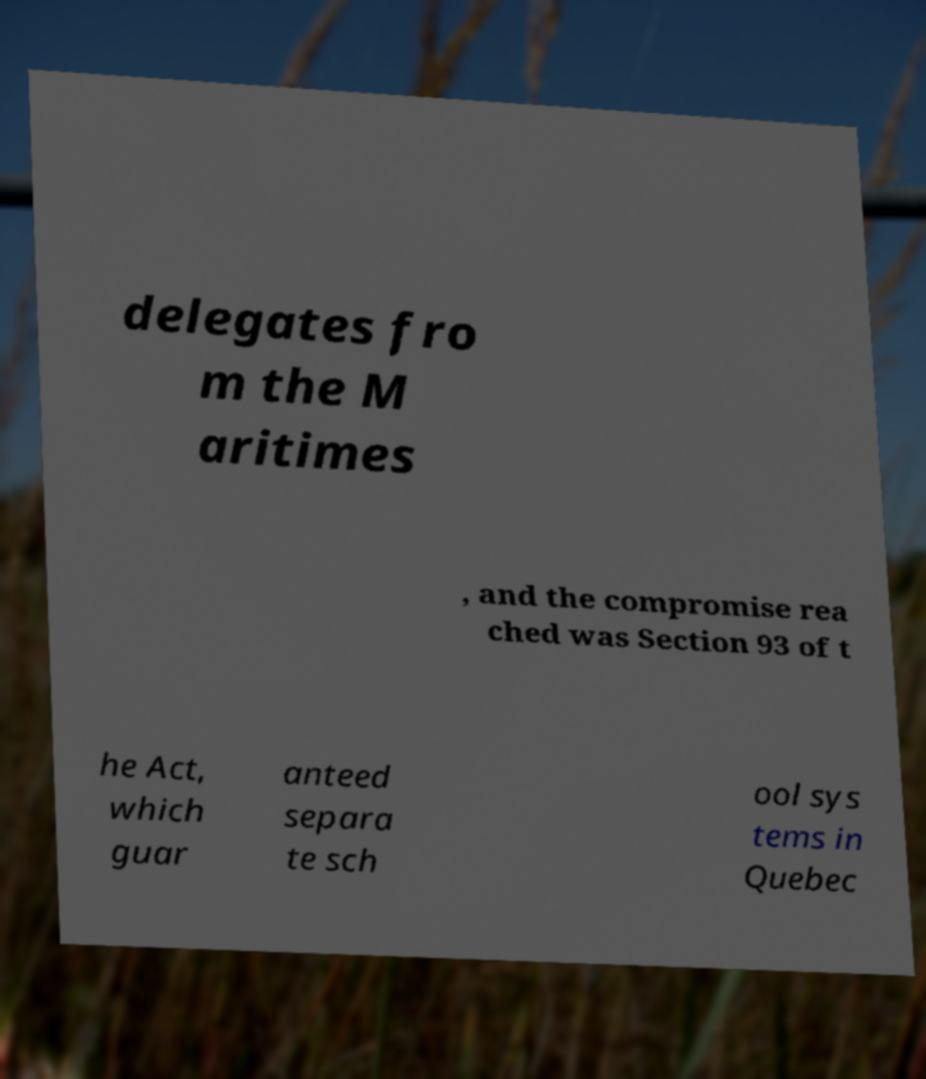Please read and relay the text visible in this image. What does it say? delegates fro m the M aritimes , and the compromise rea ched was Section 93 of t he Act, which guar anteed separa te sch ool sys tems in Quebec 